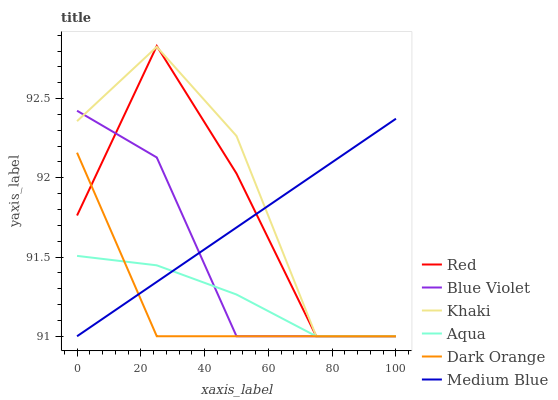Does Dark Orange have the minimum area under the curve?
Answer yes or no. Yes. Does Khaki have the maximum area under the curve?
Answer yes or no. Yes. Does Aqua have the minimum area under the curve?
Answer yes or no. No. Does Aqua have the maximum area under the curve?
Answer yes or no. No. Is Medium Blue the smoothest?
Answer yes or no. Yes. Is Red the roughest?
Answer yes or no. Yes. Is Khaki the smoothest?
Answer yes or no. No. Is Khaki the roughest?
Answer yes or no. No. Does Dark Orange have the lowest value?
Answer yes or no. Yes. Does Red have the highest value?
Answer yes or no. Yes. Does Khaki have the highest value?
Answer yes or no. No. Does Khaki intersect Aqua?
Answer yes or no. Yes. Is Khaki less than Aqua?
Answer yes or no. No. Is Khaki greater than Aqua?
Answer yes or no. No. 